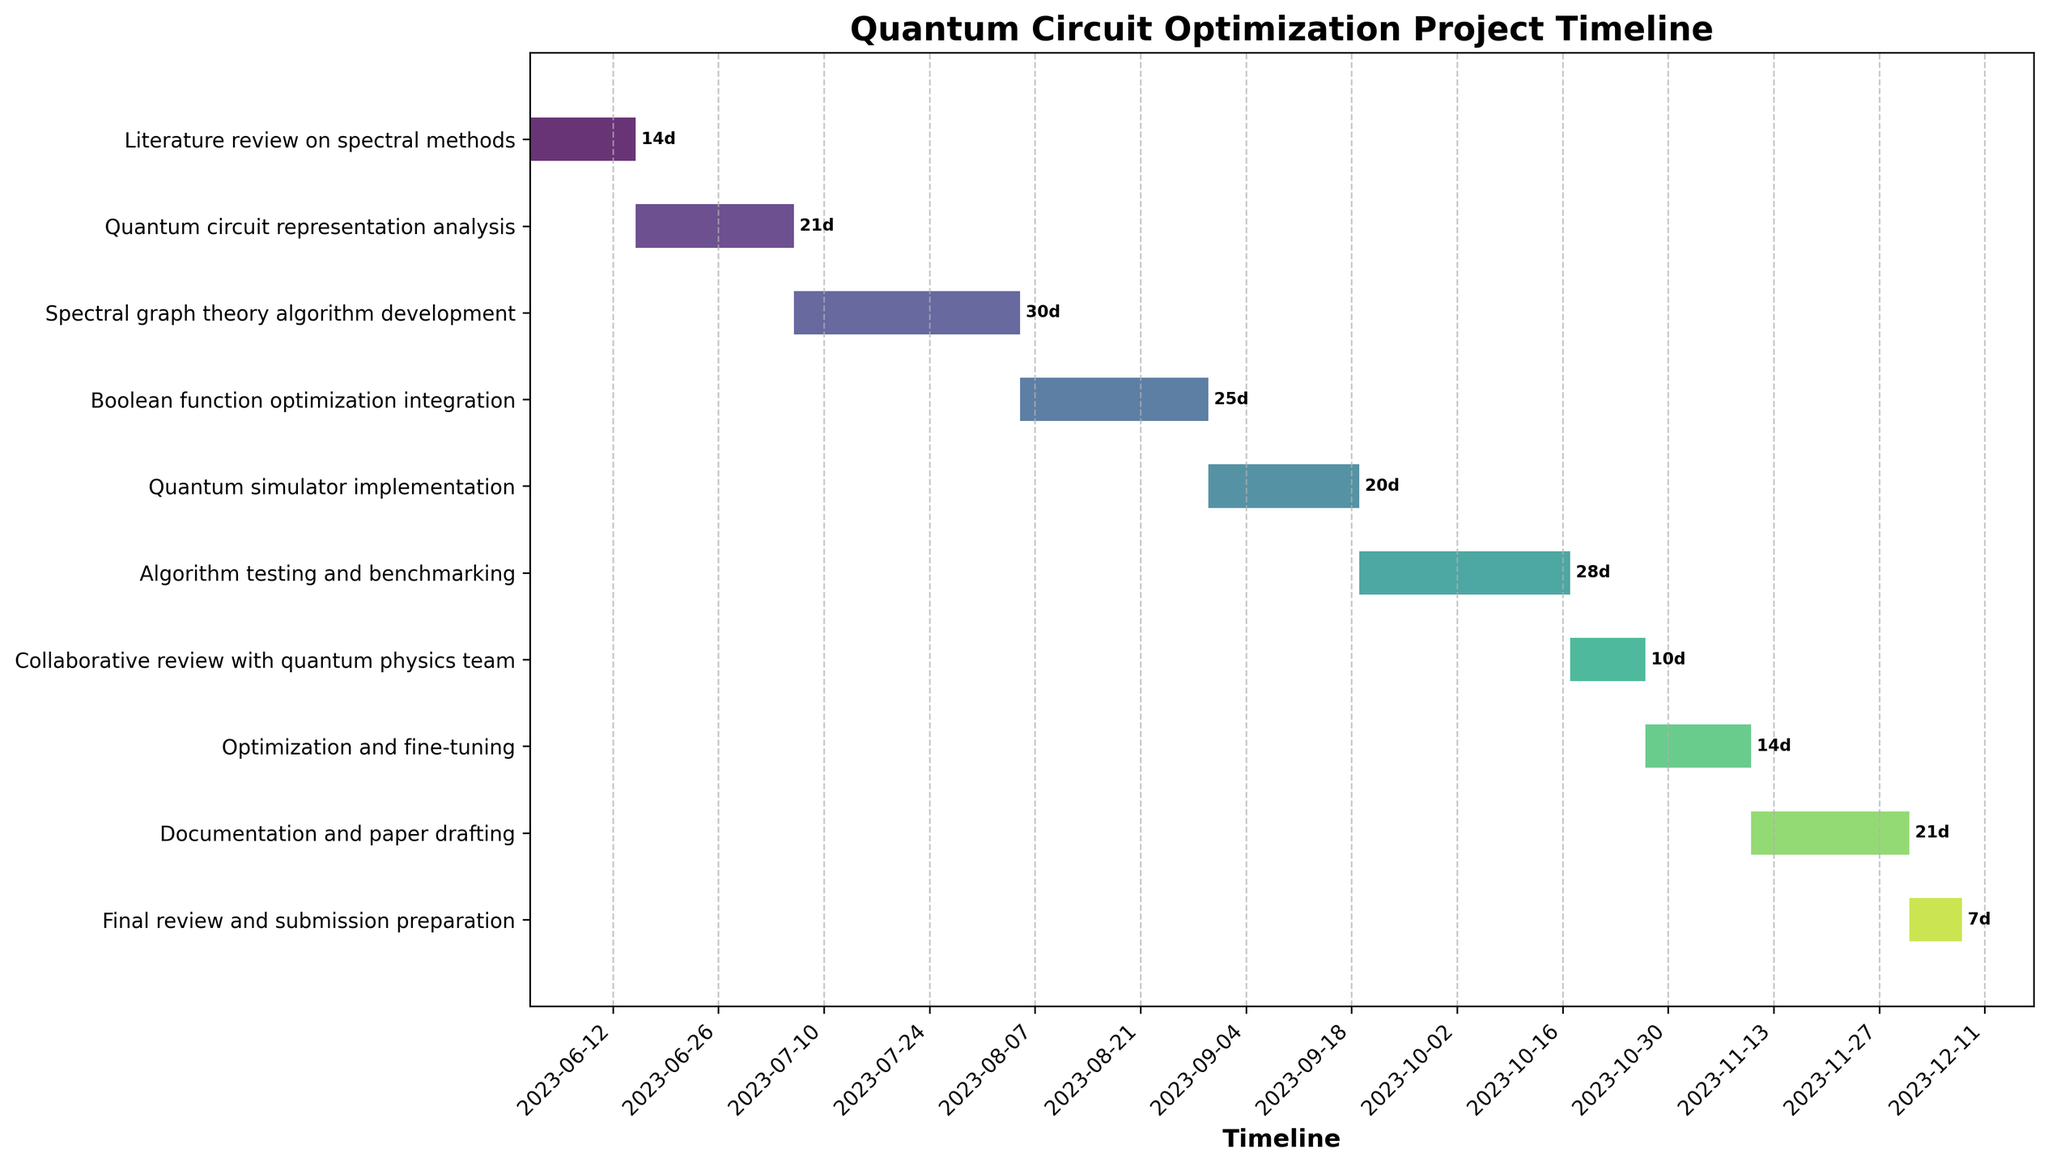What is the title of the Gantt Chart? The title is usually located at the top of the figure and it is clearly legible. Reading the text at the top helps to identify the title.
Answer: Quantum Circuit Optimization Project Timeline When does the "Quantum simulator implementation" phase start and end? Locate the start and end points of the bar labeled "Quantum simulator implementation" on the Gantt Chart. The start date is marked by the left edge of the bar and the end date by the right edge.
Answer: Starts on 2023-08-30 and ends on 2023-09-19 How long is the "Algorithm testing and benchmarking" phase? Identify the bar labeled "Algorithm testing and benchmarking" and check the duration label at the right end of the bar. The duration is indicated in days.
Answer: 28 days Which task starts first in the project timeline? Compare the start dates of all the tasks by looking at which bar starts the earliest on the horizontal axis. The task to the leftmost is the earliest starting task.
Answer: Literature review on spectral methods What is the total duration from the start of the project to the end of the "Documentation and paper drafting" phase? The first task starts on 2023-06-01 and "Documentation and paper drafting" ends on 2023-12-01. Calculate the total duration in days by counting from the start to the end date.
Answer: Approximately 183 days Which phase has the shortest duration and how many days does it last? Survey all the bars on the Gantt Chart to identify the shortest one. Check the duration label next to that specific bar to find the exact duration in days.
Answer: Final review and submission preparation, 7 days Compare the durations of "Spectral graph theory algorithm development" and "Optimization and fine-tuning." Which one takes longer and by how many days? Check the duration labels next to each of the bars labeled "Spectral graph theory algorithm development" and "Optimization and fine-tuning." Subtract the shorter duration from the longer one to find the difference.
Answer: Spectral graph theory algorithm development takes longer by 16 days When does the collaborative review with the quantum physics team begin? Identify the bar labeled "Collaborative review with quantum physics team" and read its leftmost start date. This indicates when the phase begins.
Answer: 2023-10-17 What is the gap in days between the end of the "Boolean function optimization integration" phase and the start of the "Quantum simulator implementation" phase? Identify the end date of "Boolean function optimization integration" and the start date of the "Quantum simulator implementation." Calculate the number of days between these two dates.
Answer: There is no gap; the phases are consecutive Explain the sequence of tasks from "Optimization and fine-tuning" to "Final review and submission preparation". Identify the order of tasks by reading the labels of the bars and following the timeline from the end of "Optimization and fine-tuning" until the start of "Final review and submission preparation." Describe the tasks in chronological order.
Answer: Optimization and fine-tuning (2023-10-27 to 2023-11-10), Documentation and paper drafting (2023-11-10 to 2023-12-01), and Final review and submission preparation (2023-12-01 to 2023-12-08) 